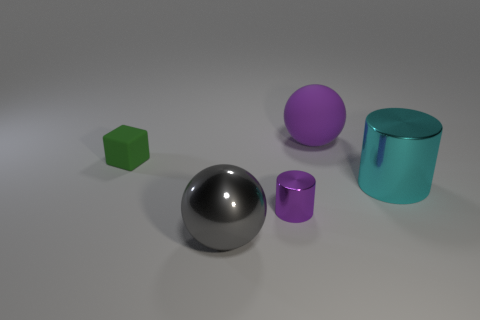How many cubes are big purple matte things or small purple shiny things?
Your response must be concise. 0. There is a thing on the right side of the big purple rubber object; what is its color?
Provide a succinct answer. Cyan. There is a small thing that is the same color as the matte ball; what shape is it?
Make the answer very short. Cylinder. How many gray balls have the same size as the purple matte thing?
Your response must be concise. 1. Do the big object behind the cube and the big object to the left of the rubber ball have the same shape?
Give a very brief answer. Yes. What material is the cylinder that is on the left side of the large metallic object that is right of the big object left of the large purple ball?
Offer a terse response. Metal. There is a gray metallic object that is the same size as the cyan cylinder; what is its shape?
Ensure brevity in your answer.  Sphere. Is there a large rubber thing of the same color as the tiny shiny cylinder?
Ensure brevity in your answer.  Yes. What is the size of the cyan metal thing?
Your answer should be very brief. Large. Is the green thing made of the same material as the big cyan cylinder?
Keep it short and to the point. No. 